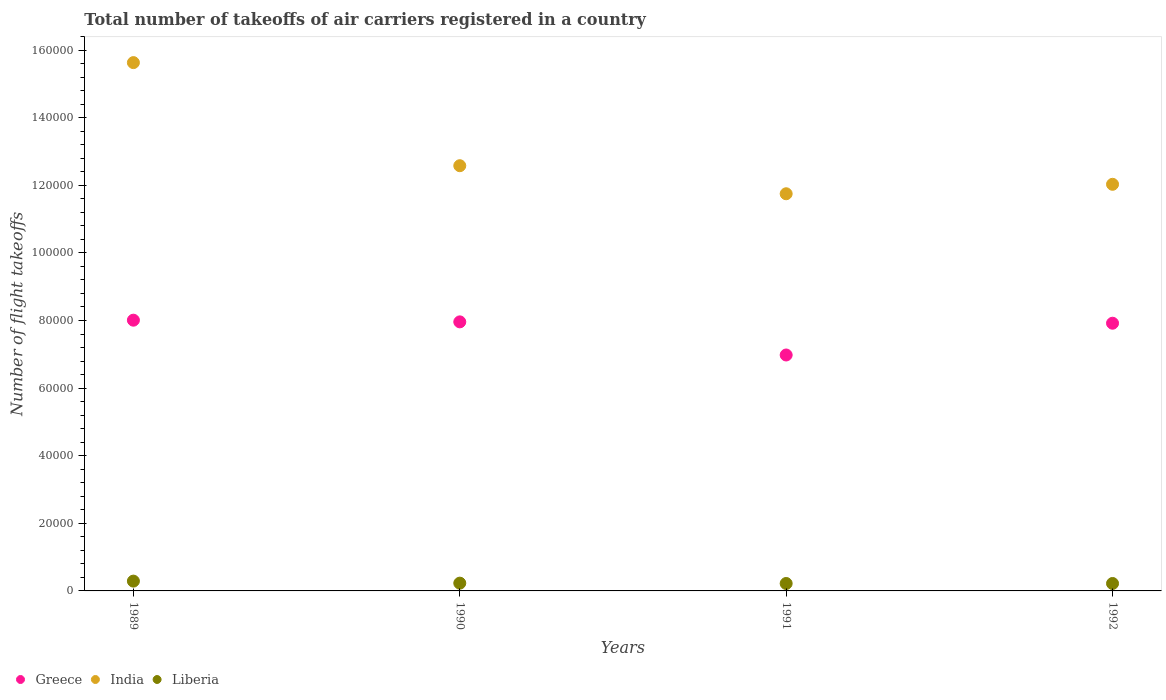Is the number of dotlines equal to the number of legend labels?
Offer a very short reply. Yes. What is the total number of flight takeoffs in Liberia in 1990?
Offer a very short reply. 2300. Across all years, what is the maximum total number of flight takeoffs in Liberia?
Your answer should be compact. 2900. Across all years, what is the minimum total number of flight takeoffs in India?
Keep it short and to the point. 1.18e+05. In which year was the total number of flight takeoffs in India minimum?
Make the answer very short. 1991. What is the total total number of flight takeoffs in India in the graph?
Give a very brief answer. 5.20e+05. What is the difference between the total number of flight takeoffs in India in 1990 and that in 1991?
Keep it short and to the point. 8300. What is the difference between the total number of flight takeoffs in India in 1991 and the total number of flight takeoffs in Greece in 1990?
Offer a very short reply. 3.79e+04. What is the average total number of flight takeoffs in Liberia per year?
Your response must be concise. 2400. In the year 1989, what is the difference between the total number of flight takeoffs in Greece and total number of flight takeoffs in India?
Offer a very short reply. -7.62e+04. In how many years, is the total number of flight takeoffs in Greece greater than 64000?
Ensure brevity in your answer.  4. What is the ratio of the total number of flight takeoffs in India in 1990 to that in 1991?
Give a very brief answer. 1.07. What is the difference between the highest and the second highest total number of flight takeoffs in Liberia?
Offer a very short reply. 600. What is the difference between the highest and the lowest total number of flight takeoffs in India?
Ensure brevity in your answer.  3.88e+04. Is it the case that in every year, the sum of the total number of flight takeoffs in Liberia and total number of flight takeoffs in India  is greater than the total number of flight takeoffs in Greece?
Provide a short and direct response. Yes. Does the total number of flight takeoffs in Greece monotonically increase over the years?
Your answer should be compact. No. Is the total number of flight takeoffs in Greece strictly greater than the total number of flight takeoffs in Liberia over the years?
Your response must be concise. Yes. How many dotlines are there?
Your response must be concise. 3. How many years are there in the graph?
Provide a short and direct response. 4. Does the graph contain any zero values?
Your answer should be compact. No. Does the graph contain grids?
Keep it short and to the point. No. How many legend labels are there?
Your answer should be compact. 3. What is the title of the graph?
Offer a very short reply. Total number of takeoffs of air carriers registered in a country. What is the label or title of the Y-axis?
Ensure brevity in your answer.  Number of flight takeoffs. What is the Number of flight takeoffs of Greece in 1989?
Make the answer very short. 8.01e+04. What is the Number of flight takeoffs of India in 1989?
Your response must be concise. 1.56e+05. What is the Number of flight takeoffs in Liberia in 1989?
Ensure brevity in your answer.  2900. What is the Number of flight takeoffs in Greece in 1990?
Give a very brief answer. 7.96e+04. What is the Number of flight takeoffs in India in 1990?
Your answer should be very brief. 1.26e+05. What is the Number of flight takeoffs in Liberia in 1990?
Your answer should be very brief. 2300. What is the Number of flight takeoffs in Greece in 1991?
Keep it short and to the point. 6.98e+04. What is the Number of flight takeoffs of India in 1991?
Your response must be concise. 1.18e+05. What is the Number of flight takeoffs of Liberia in 1991?
Ensure brevity in your answer.  2200. What is the Number of flight takeoffs of Greece in 1992?
Make the answer very short. 7.92e+04. What is the Number of flight takeoffs of India in 1992?
Your answer should be very brief. 1.20e+05. What is the Number of flight takeoffs in Liberia in 1992?
Provide a succinct answer. 2200. Across all years, what is the maximum Number of flight takeoffs in Greece?
Offer a terse response. 8.01e+04. Across all years, what is the maximum Number of flight takeoffs of India?
Ensure brevity in your answer.  1.56e+05. Across all years, what is the maximum Number of flight takeoffs in Liberia?
Ensure brevity in your answer.  2900. Across all years, what is the minimum Number of flight takeoffs of Greece?
Make the answer very short. 6.98e+04. Across all years, what is the minimum Number of flight takeoffs in India?
Give a very brief answer. 1.18e+05. Across all years, what is the minimum Number of flight takeoffs in Liberia?
Ensure brevity in your answer.  2200. What is the total Number of flight takeoffs in Greece in the graph?
Your response must be concise. 3.09e+05. What is the total Number of flight takeoffs in India in the graph?
Your response must be concise. 5.20e+05. What is the total Number of flight takeoffs of Liberia in the graph?
Ensure brevity in your answer.  9600. What is the difference between the Number of flight takeoffs of India in 1989 and that in 1990?
Offer a very short reply. 3.05e+04. What is the difference between the Number of flight takeoffs of Liberia in 1989 and that in 1990?
Your response must be concise. 600. What is the difference between the Number of flight takeoffs of Greece in 1989 and that in 1991?
Provide a succinct answer. 1.03e+04. What is the difference between the Number of flight takeoffs of India in 1989 and that in 1991?
Offer a very short reply. 3.88e+04. What is the difference between the Number of flight takeoffs of Liberia in 1989 and that in 1991?
Make the answer very short. 700. What is the difference between the Number of flight takeoffs in Greece in 1989 and that in 1992?
Provide a short and direct response. 900. What is the difference between the Number of flight takeoffs in India in 1989 and that in 1992?
Provide a succinct answer. 3.60e+04. What is the difference between the Number of flight takeoffs in Liberia in 1989 and that in 1992?
Your answer should be compact. 700. What is the difference between the Number of flight takeoffs of Greece in 1990 and that in 1991?
Provide a short and direct response. 9800. What is the difference between the Number of flight takeoffs of India in 1990 and that in 1991?
Your answer should be very brief. 8300. What is the difference between the Number of flight takeoffs in Liberia in 1990 and that in 1991?
Your answer should be compact. 100. What is the difference between the Number of flight takeoffs of India in 1990 and that in 1992?
Your answer should be compact. 5500. What is the difference between the Number of flight takeoffs of Liberia in 1990 and that in 1992?
Your answer should be very brief. 100. What is the difference between the Number of flight takeoffs of Greece in 1991 and that in 1992?
Offer a terse response. -9400. What is the difference between the Number of flight takeoffs in India in 1991 and that in 1992?
Provide a succinct answer. -2800. What is the difference between the Number of flight takeoffs of Greece in 1989 and the Number of flight takeoffs of India in 1990?
Your answer should be very brief. -4.57e+04. What is the difference between the Number of flight takeoffs of Greece in 1989 and the Number of flight takeoffs of Liberia in 1990?
Provide a succinct answer. 7.78e+04. What is the difference between the Number of flight takeoffs of India in 1989 and the Number of flight takeoffs of Liberia in 1990?
Provide a short and direct response. 1.54e+05. What is the difference between the Number of flight takeoffs of Greece in 1989 and the Number of flight takeoffs of India in 1991?
Offer a very short reply. -3.74e+04. What is the difference between the Number of flight takeoffs in Greece in 1989 and the Number of flight takeoffs in Liberia in 1991?
Ensure brevity in your answer.  7.79e+04. What is the difference between the Number of flight takeoffs of India in 1989 and the Number of flight takeoffs of Liberia in 1991?
Your answer should be very brief. 1.54e+05. What is the difference between the Number of flight takeoffs in Greece in 1989 and the Number of flight takeoffs in India in 1992?
Provide a succinct answer. -4.02e+04. What is the difference between the Number of flight takeoffs in Greece in 1989 and the Number of flight takeoffs in Liberia in 1992?
Provide a short and direct response. 7.79e+04. What is the difference between the Number of flight takeoffs of India in 1989 and the Number of flight takeoffs of Liberia in 1992?
Your response must be concise. 1.54e+05. What is the difference between the Number of flight takeoffs in Greece in 1990 and the Number of flight takeoffs in India in 1991?
Offer a terse response. -3.79e+04. What is the difference between the Number of flight takeoffs of Greece in 1990 and the Number of flight takeoffs of Liberia in 1991?
Keep it short and to the point. 7.74e+04. What is the difference between the Number of flight takeoffs in India in 1990 and the Number of flight takeoffs in Liberia in 1991?
Your response must be concise. 1.24e+05. What is the difference between the Number of flight takeoffs of Greece in 1990 and the Number of flight takeoffs of India in 1992?
Give a very brief answer. -4.07e+04. What is the difference between the Number of flight takeoffs in Greece in 1990 and the Number of flight takeoffs in Liberia in 1992?
Your response must be concise. 7.74e+04. What is the difference between the Number of flight takeoffs in India in 1990 and the Number of flight takeoffs in Liberia in 1992?
Offer a very short reply. 1.24e+05. What is the difference between the Number of flight takeoffs of Greece in 1991 and the Number of flight takeoffs of India in 1992?
Make the answer very short. -5.05e+04. What is the difference between the Number of flight takeoffs in Greece in 1991 and the Number of flight takeoffs in Liberia in 1992?
Your answer should be compact. 6.76e+04. What is the difference between the Number of flight takeoffs in India in 1991 and the Number of flight takeoffs in Liberia in 1992?
Offer a very short reply. 1.15e+05. What is the average Number of flight takeoffs in Greece per year?
Your response must be concise. 7.72e+04. What is the average Number of flight takeoffs of India per year?
Provide a succinct answer. 1.30e+05. What is the average Number of flight takeoffs of Liberia per year?
Your answer should be compact. 2400. In the year 1989, what is the difference between the Number of flight takeoffs in Greece and Number of flight takeoffs in India?
Your answer should be very brief. -7.62e+04. In the year 1989, what is the difference between the Number of flight takeoffs in Greece and Number of flight takeoffs in Liberia?
Give a very brief answer. 7.72e+04. In the year 1989, what is the difference between the Number of flight takeoffs of India and Number of flight takeoffs of Liberia?
Ensure brevity in your answer.  1.53e+05. In the year 1990, what is the difference between the Number of flight takeoffs in Greece and Number of flight takeoffs in India?
Offer a terse response. -4.62e+04. In the year 1990, what is the difference between the Number of flight takeoffs of Greece and Number of flight takeoffs of Liberia?
Provide a succinct answer. 7.73e+04. In the year 1990, what is the difference between the Number of flight takeoffs in India and Number of flight takeoffs in Liberia?
Provide a succinct answer. 1.24e+05. In the year 1991, what is the difference between the Number of flight takeoffs in Greece and Number of flight takeoffs in India?
Ensure brevity in your answer.  -4.77e+04. In the year 1991, what is the difference between the Number of flight takeoffs of Greece and Number of flight takeoffs of Liberia?
Ensure brevity in your answer.  6.76e+04. In the year 1991, what is the difference between the Number of flight takeoffs of India and Number of flight takeoffs of Liberia?
Provide a succinct answer. 1.15e+05. In the year 1992, what is the difference between the Number of flight takeoffs of Greece and Number of flight takeoffs of India?
Ensure brevity in your answer.  -4.11e+04. In the year 1992, what is the difference between the Number of flight takeoffs of Greece and Number of flight takeoffs of Liberia?
Give a very brief answer. 7.70e+04. In the year 1992, what is the difference between the Number of flight takeoffs in India and Number of flight takeoffs in Liberia?
Provide a succinct answer. 1.18e+05. What is the ratio of the Number of flight takeoffs in India in 1989 to that in 1990?
Provide a succinct answer. 1.24. What is the ratio of the Number of flight takeoffs of Liberia in 1989 to that in 1990?
Provide a short and direct response. 1.26. What is the ratio of the Number of flight takeoffs of Greece in 1989 to that in 1991?
Your answer should be very brief. 1.15. What is the ratio of the Number of flight takeoffs in India in 1989 to that in 1991?
Make the answer very short. 1.33. What is the ratio of the Number of flight takeoffs of Liberia in 1989 to that in 1991?
Give a very brief answer. 1.32. What is the ratio of the Number of flight takeoffs of Greece in 1989 to that in 1992?
Ensure brevity in your answer.  1.01. What is the ratio of the Number of flight takeoffs in India in 1989 to that in 1992?
Your response must be concise. 1.3. What is the ratio of the Number of flight takeoffs in Liberia in 1989 to that in 1992?
Make the answer very short. 1.32. What is the ratio of the Number of flight takeoffs of Greece in 1990 to that in 1991?
Provide a succinct answer. 1.14. What is the ratio of the Number of flight takeoffs of India in 1990 to that in 1991?
Offer a very short reply. 1.07. What is the ratio of the Number of flight takeoffs in Liberia in 1990 to that in 1991?
Your answer should be compact. 1.05. What is the ratio of the Number of flight takeoffs in India in 1990 to that in 1992?
Provide a short and direct response. 1.05. What is the ratio of the Number of flight takeoffs in Liberia in 1990 to that in 1992?
Provide a succinct answer. 1.05. What is the ratio of the Number of flight takeoffs of Greece in 1991 to that in 1992?
Your response must be concise. 0.88. What is the ratio of the Number of flight takeoffs in India in 1991 to that in 1992?
Give a very brief answer. 0.98. What is the difference between the highest and the second highest Number of flight takeoffs of Greece?
Give a very brief answer. 500. What is the difference between the highest and the second highest Number of flight takeoffs in India?
Give a very brief answer. 3.05e+04. What is the difference between the highest and the second highest Number of flight takeoffs in Liberia?
Keep it short and to the point. 600. What is the difference between the highest and the lowest Number of flight takeoffs of Greece?
Give a very brief answer. 1.03e+04. What is the difference between the highest and the lowest Number of flight takeoffs of India?
Your answer should be compact. 3.88e+04. What is the difference between the highest and the lowest Number of flight takeoffs of Liberia?
Give a very brief answer. 700. 